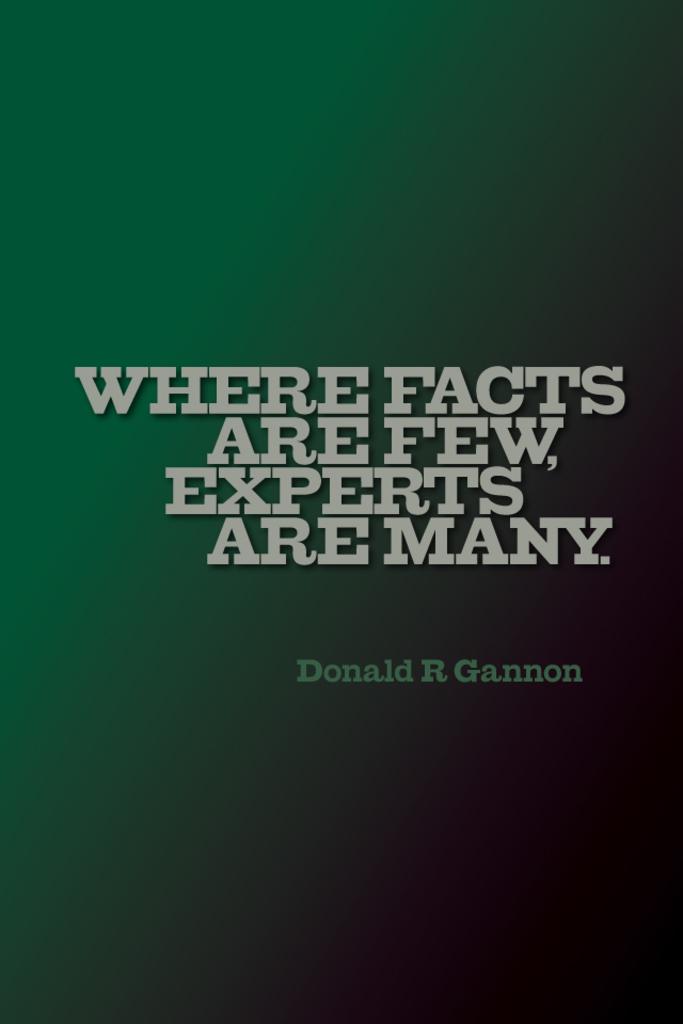Who is the author of this quote?
Offer a terse response. Donald r gannon. What is the quote?
Ensure brevity in your answer.  Where facts are few, experts are many. 